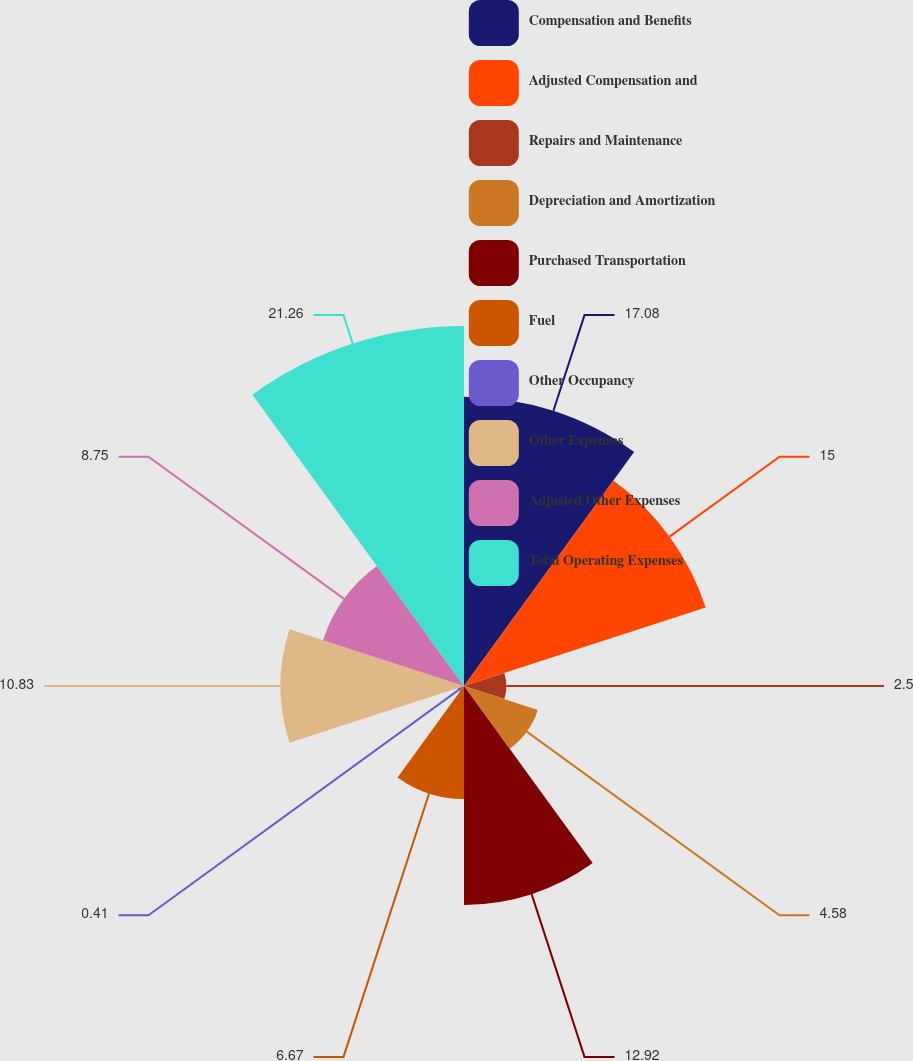Convert chart to OTSL. <chart><loc_0><loc_0><loc_500><loc_500><pie_chart><fcel>Compensation and Benefits<fcel>Adjusted Compensation and<fcel>Repairs and Maintenance<fcel>Depreciation and Amortization<fcel>Purchased Transportation<fcel>Fuel<fcel>Other Occupancy<fcel>Other Expenses<fcel>Adjusted Other Expenses<fcel>Total Operating Expenses<nl><fcel>17.08%<fcel>15.0%<fcel>2.5%<fcel>4.58%<fcel>12.92%<fcel>6.67%<fcel>0.41%<fcel>10.83%<fcel>8.75%<fcel>21.25%<nl></chart> 